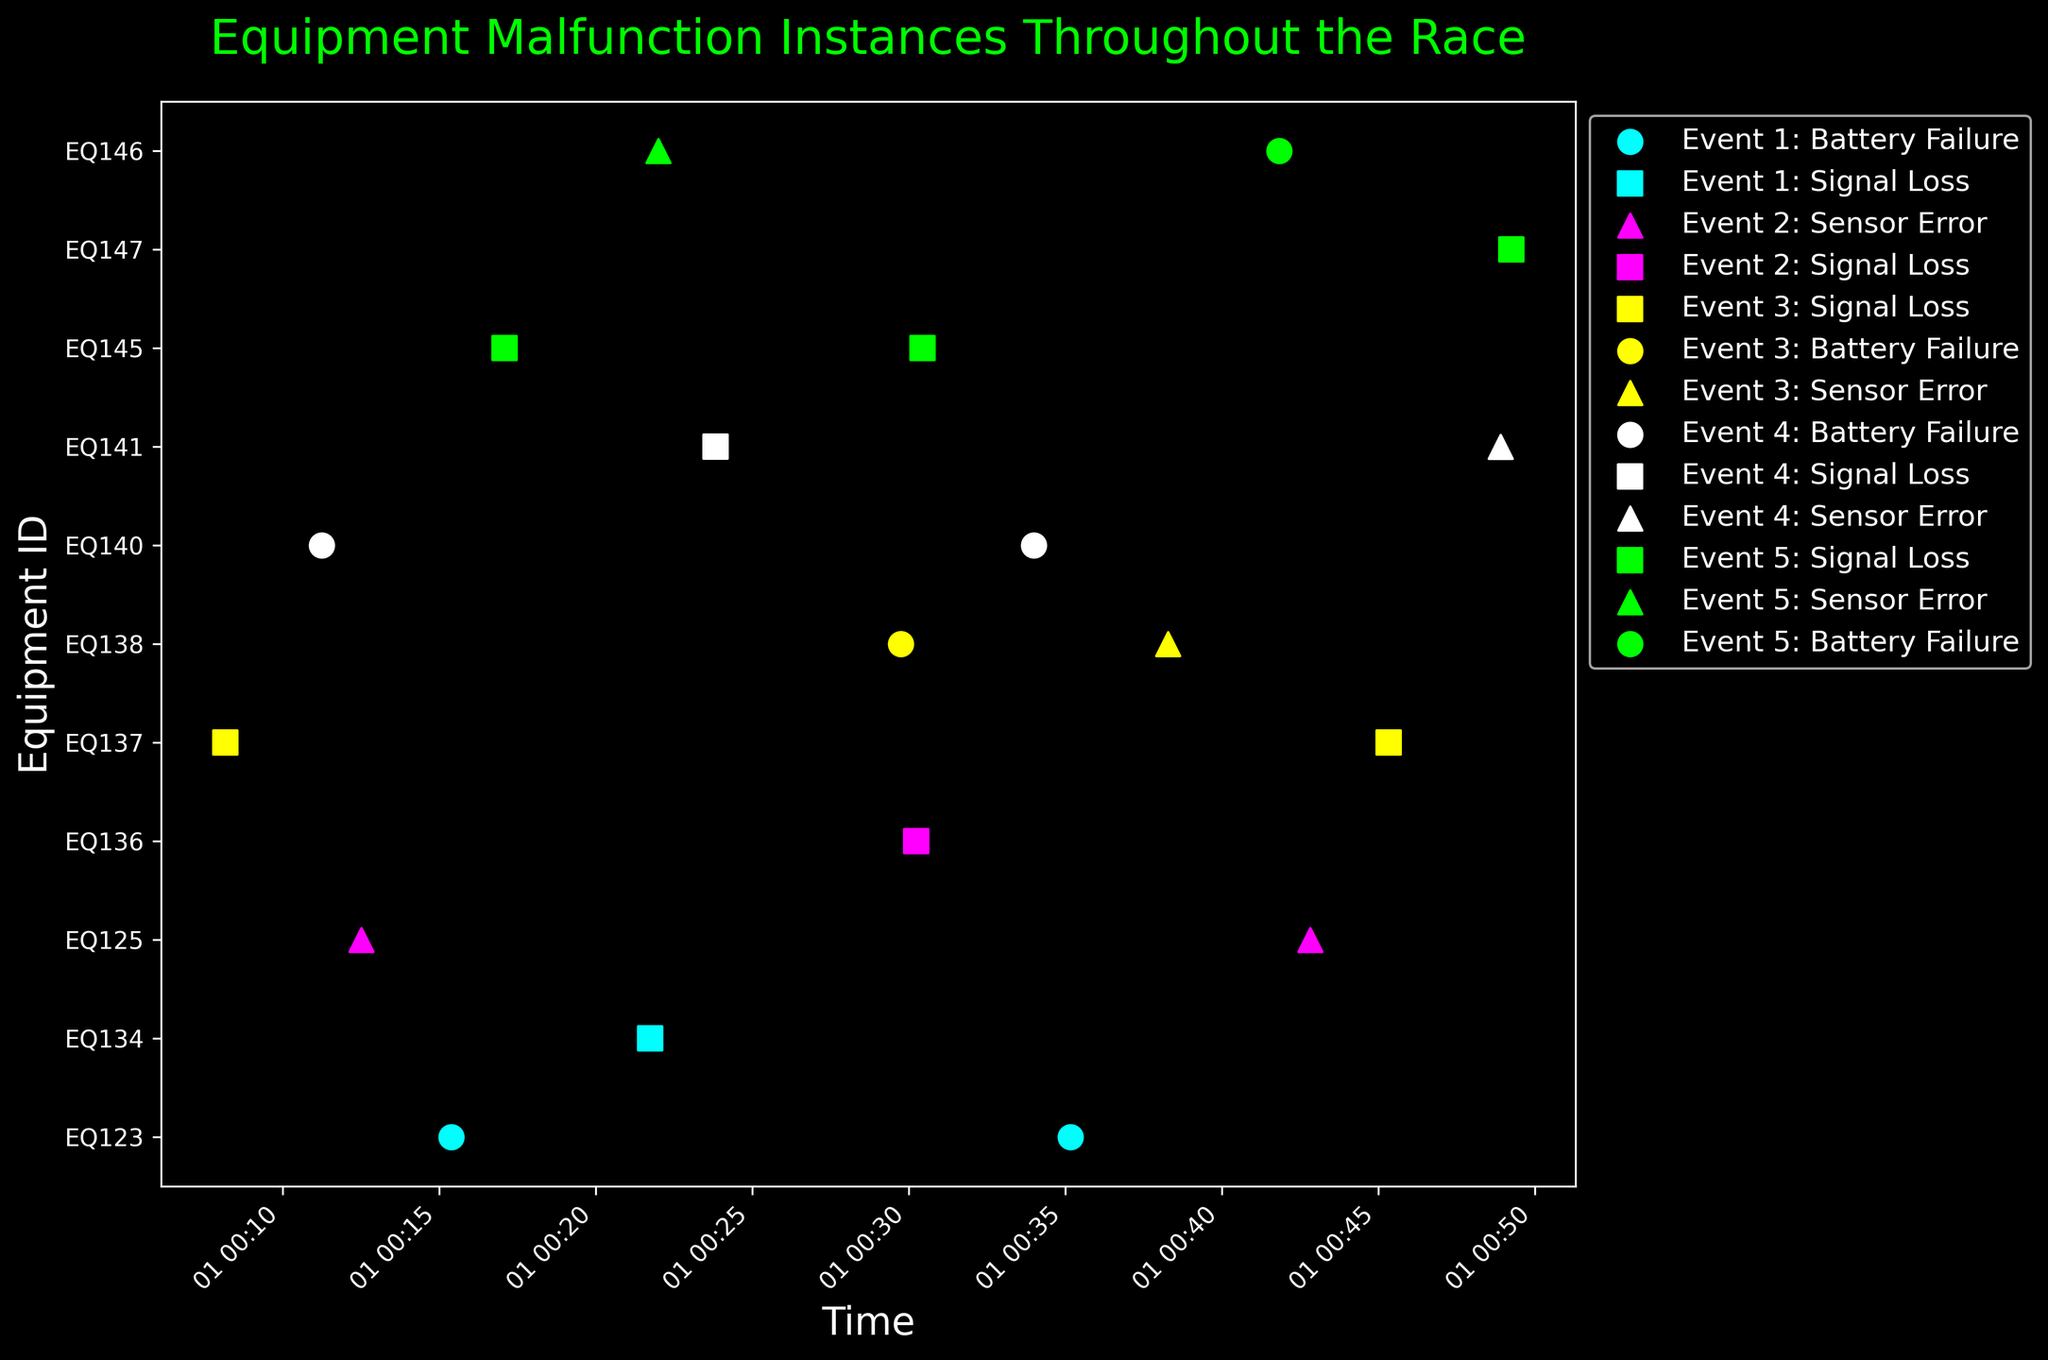What is the most common malfunction type observed in Event 1? To find the most common malfunction type in Event 1, look at the markers and count the occurrences of each type. Battery Failure appears twice, Signal Loss appears once.
Answer: Battery Failure Which equipment had the most frequent malfunctions across all events? Count the instances of malfunctions for each Equipment ID across all events. EQ137 and EQ146 both have three malfunctions.
Answer: EQ137 and EQ146 Between Event 3 and Event 5, which one had more Sensor Errors? Look at the markers for Sensor Errors (triangles). Event 3 has one Sensor Error (EQ138), and Event 5 also has one Sensor Error (EQ146).
Answer: Same How many equipment failures related to Battery Failure occurred in Event 4? Look for circular markers in Event 4 and count them. Battery Failures occurred twice for EQ140.
Answer: 2 Which event had the earliest malfunction, and what type was it? Check the earliest time points for each Event. The earliest malfunction is in Event 3 at 00:08:10, which was a Signal Loss for EQ137.
Answer: Event 3, Signal Loss Compare the malfunction frequencies between Signal Loss and Sensor Error. Which one occurred more often? Count the total occurrences of each malfunction type. Signal Loss appears 9 times, and Sensor Error appears 7 times.
Answer: Signal Loss What is the pattern of malfunctions for EQ138 in Event 3? Observe the markers for EQ138 in Event 3. There is one Battery Failure and one Sensor Error for EQ138 in Event 3.
Answer: Battery Failure, Sensor Error Are there any events where the same equipment had multiple types of malfunctions? If so, provide an example. Look for Equipment IDs that appear more than once within the same event with different malfunction types. For instance, in Event 3, EQ138 had a Battery Failure and a Sensor Error.
Answer: Yes, EQ138 in Event 3 What is the latest time a malfunction occurred in Event 5, and what type was it? Find the latest timestamp for Event 5. The latest malfunction occurred at 00:49:15, and it was a Signal Loss for EQ147.
Answer: 00:49:15, Signal Loss Which event had the highest number of malfunctions overall? Count the total malfunctions for each event. Event 5 has the highest number, with five malfunctions.
Answer: Event 5 